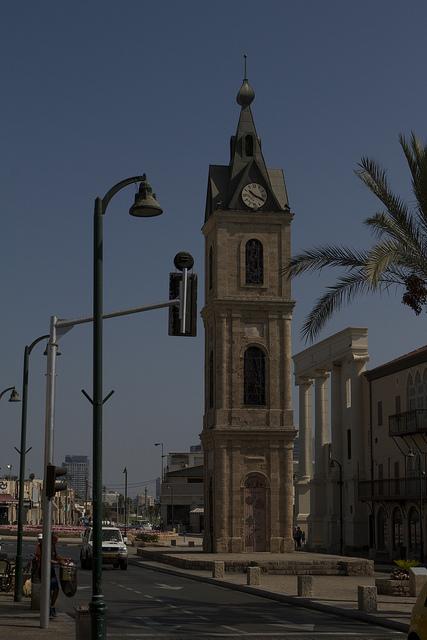What type of roof structure does the building in the center background have?
Concise answer only. Steeple. How many stories are in the center building?
Keep it brief. 3. Is the street crowded?
Short answer required. No. Is this in London?
Concise answer only. No. Which direction is the arrow on the ground pointing?
Quick response, please. Down. How many black and white poles are there?
Write a very short answer. 0. What type of tree is in this photo?
Be succinct. Palm. Has it recently rained?
Give a very brief answer. No. Is it snowing?
Be succinct. No. Does the clock emit light?
Short answer required. No. What type of large structure is visible in this photo?
Concise answer only. Clock tower. Are vehicles supposed to go down this road?
Write a very short answer. Yes. Is there an exit sign?
Quick response, please. No. What items are on top of the buildings to the right?
Short answer required. Clock. How many newspaper vending machines are there?
Concise answer only. 0. What buildings are shown?
Keep it brief. Clock tower. How many types of automobiles are in the photo?
Keep it brief. 1. Is this a hilly area?
Write a very short answer. No. Where is the car either going or been?
Give a very brief answer. New mexico. What number is on the street?
Quick response, please. No number. What's on the poles in the background?
Short answer required. Lights. What do the clocks say?
Write a very short answer. 10:20. Is there construction going on?
Concise answer only. No. Is this a stand-alone clock tower?
Concise answer only. Yes. Is it daytime or nighttime?
Answer briefly. Daytime. Are this fire hydrants?
Keep it brief. No. What kind of car is the little white one?
Be succinct. Jeep. What is on top of the traffic light pole?
Be succinct. Light. Is the street too narrow?
Concise answer only. No. What is on the pole in the very back?
Be succinct. Light. Is the sun bright?
Quick response, please. No. What time does the clock say?
Concise answer only. 10:20. What kind of stands are on either side of the clock?
Concise answer only. Concrete. Are the trees leafy?
Answer briefly. Yes. What color is the clock?
Short answer required. White. How many hours past tea-time does this clock read?
Answer briefly. 20. Where is Jamba Juice?
Concise answer only. Not here. Are the streets crowded?
Be succinct. No. Is this photo askew?
Short answer required. No. Is the picture right side up?
Write a very short answer. Yes. What time of day is this?
Write a very short answer. Morning. Is it sunny?
Be succinct. Yes. Where is this photo taken?
Be succinct. Downtown. What are the stripes on the road for?
Be succinct. Direction. Is the building wheelchair accessible?
Keep it brief. No. Using a 24 hour time format, what time is it?
Concise answer only. 10:20. What is the clock tower made out of?
Give a very brief answer. Bricks. Is the sun shining?
Write a very short answer. Yes. Is there a basketball goal?
Quick response, please. No. What time is it?
Answer briefly. 10:20. How many buildings are shown?
Quick response, please. 4. Is there a grassy area?
Quick response, please. No. Is there a man in uniform?
Quick response, please. No. What time does the clock show?
Short answer required. 10:20. What are the columns holding up?
Write a very short answer. Tower. Is there graffiti in this photo?
Answer briefly. No. Is this an airport?
Write a very short answer. No. What time is it on the clock?
Keep it brief. 11:20. What time is on the clock?
Give a very brief answer. 10:20. Are there people in the picture?
Short answer required. No. What time does the clock on the pole show?
Answer briefly. 10:20. What kind of weather it is?
Quick response, please. Clear. Is this a colorful scene?
Give a very brief answer. No. Is there a sign?
Short answer required. No. What color is the tallest building?
Concise answer only. Brown. What color is around the clock?
Write a very short answer. Brown. Is the door closed?
Write a very short answer. Yes. Is this during the day?
Be succinct. Yes. What color is the building?
Write a very short answer. Brown. How many poles can be seen?
Short answer required. 3. Does the building in the background have shutters?
Give a very brief answer. No. Is this a street in Canada?
Keep it brief. No. What color is the car?
Quick response, please. White. What season is this?
Concise answer only. Summer. Is this a real street?
Concise answer only. Yes. How many lights can be seen?
Write a very short answer. 2. Are there any traffic lights here?
Concise answer only. Yes. Is there a US flag visible?
Be succinct. No. How many clocks are visible?
Be succinct. 1. Does it match the building?
Be succinct. No. How many hands does the clock have?
Write a very short answer. 2. Is there an office building in the picture?
Concise answer only. No. How many clock faces are there?
Write a very short answer. 1. Are any cars on the road?
Short answer required. Yes. Where is this?
Quick response, please. London. How many windows are here?
Concise answer only. 2. Is it night?
Write a very short answer. No. Is this a colorful city?
Write a very short answer. No. How many clock faces are shown?
Write a very short answer. 1. Is there a skyscraper in the background?
Be succinct. Yes. What is the name of this building?
Be succinct. Clock tower. What time of day is it?
Concise answer only. Afternoon. How many palm trees do you see?
Give a very brief answer. 1. What species of dinosaur is on top of the vehicle in the scene?
Quick response, please. 0. Why isn't the streetlight on?
Be succinct. Daytime. How many sides does the clock tower have?
Quick response, please. 4. Should a car park here?
Concise answer only. No. Are these trimmed palm trees?
Be succinct. No. How many clocks are in the picture?
Be succinct. 1. Is this a boat?
Be succinct. No. Does this seem well maintained?
Concise answer only. Yes. Where is the awning?
Keep it brief. Nowhere. Is the street light as tall as the clock tower?
Short answer required. No. What color is the rim of the clock?
Write a very short answer. Black. What is the sculpture?
Concise answer only. Building. What type of building could this be?
Concise answer only. Clock tower. What is the possibility that this location is not in USA?
Be succinct. Possible. What color are the poles?
Short answer required. Black. What type of tree is that?
Quick response, please. Palm. Is anyone walking on the street?
Short answer required. No. Are there clouds in the sky?
Give a very brief answer. No. What color is the building on the right?
Concise answer only. Tan. Is that the Tower of London?
Keep it brief. No. Is this in focus?
Give a very brief answer. Yes. Is this sign in a big city?
Concise answer only. No. What time does the clock have?
Give a very brief answer. 10:20. In which city was this photo taken?
Quick response, please. London. Is it cold here?
Quick response, please. No. Besides busses, what form of transportation is there?
Answer briefly. Cars. What time is it on the Clocktower?
Quick response, please. 11:20. Is this a color photo?
Quick response, please. Yes. Where is the water coming from?
Write a very short answer. Sky. What color are the clocks?
Keep it brief. White. Could there be a fire tower?
Concise answer only. No. Is this a car-free zone?
Keep it brief. No. Are there many wires?
Be succinct. No. Is it daytime?
Keep it brief. Yes. Is the clock transparent?
Be succinct. No. How many semaphores poles in this picture?
Write a very short answer. 0. Is it cloudy?
Write a very short answer. No. 